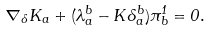<formula> <loc_0><loc_0><loc_500><loc_500>\nabla _ { \delta } K _ { a } + ( \lambda _ { a } ^ { b } - K \delta _ { a } ^ { b } ) \pi _ { b } ^ { 1 } = 0 .</formula> 